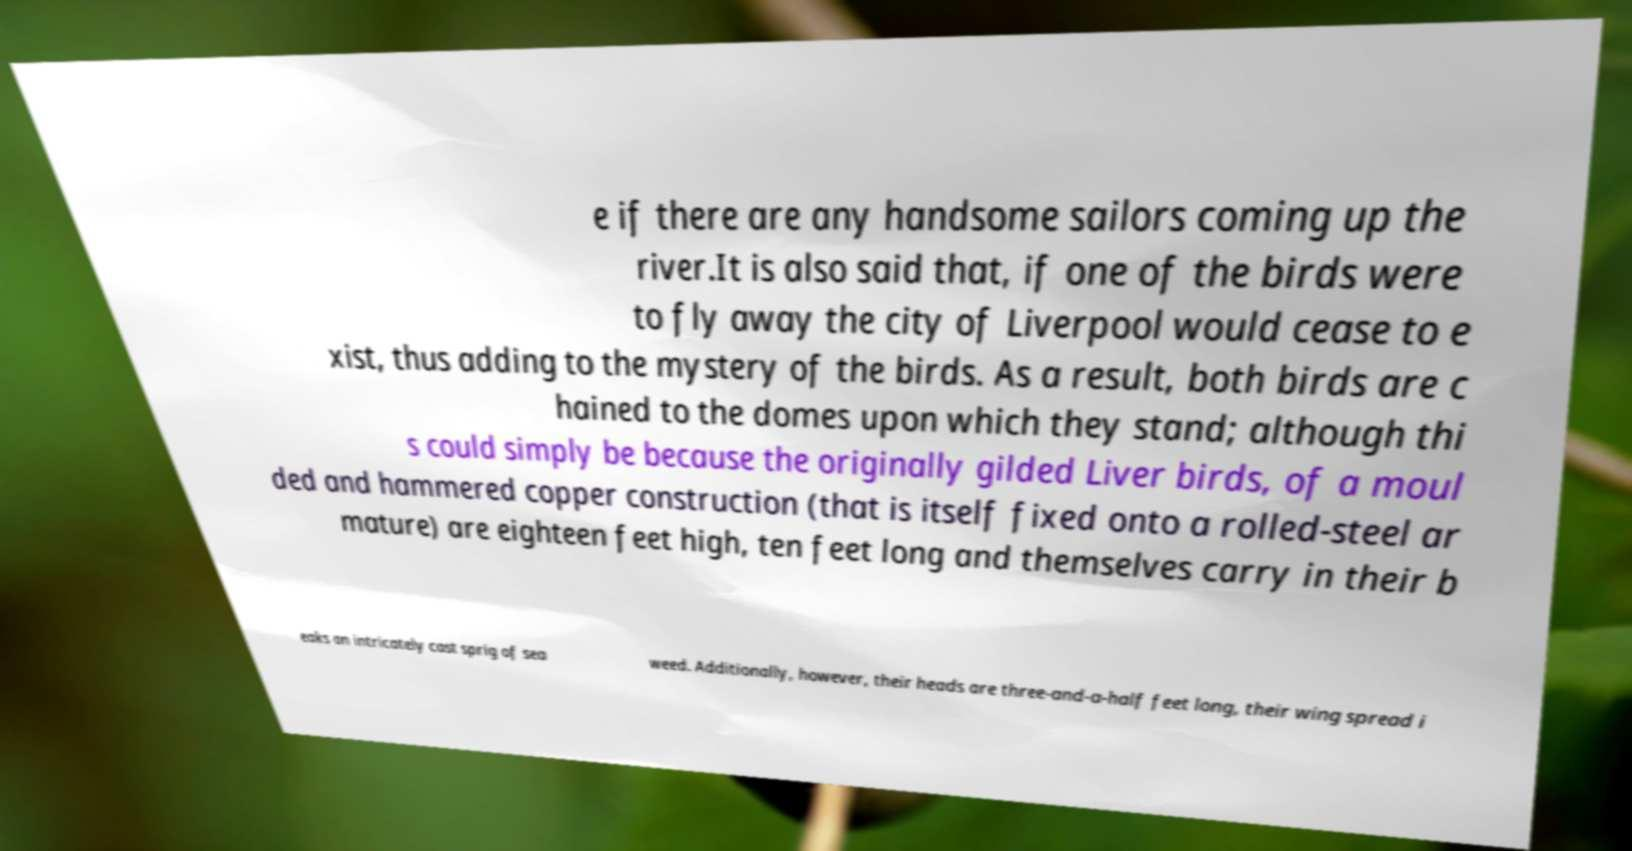I need the written content from this picture converted into text. Can you do that? e if there are any handsome sailors coming up the river.It is also said that, if one of the birds were to fly away the city of Liverpool would cease to e xist, thus adding to the mystery of the birds. As a result, both birds are c hained to the domes upon which they stand; although thi s could simply be because the originally gilded Liver birds, of a moul ded and hammered copper construction (that is itself fixed onto a rolled-steel ar mature) are eighteen feet high, ten feet long and themselves carry in their b eaks an intricately cast sprig of sea weed. Additionally, however, their heads are three-and-a-half feet long, their wing spread i 